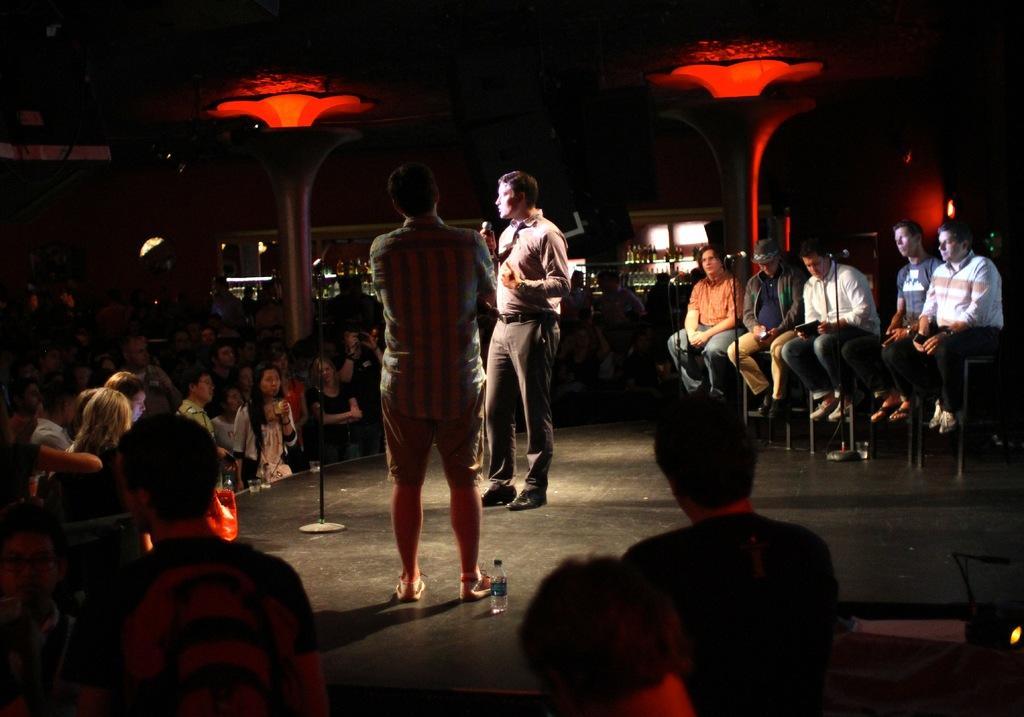Could you give a brief overview of what you see in this image? In this image there are group persons sitting on the chair, there are persons standing, there is a person standing and holding an object, there are group person's truncated towards the left of the image, there are persons truncated towards the bottom of the image, there is a stand on the ground, there is a water bottle, there is a light, there are pillars, there are bottles on the shelves, the background of the image is dark. 